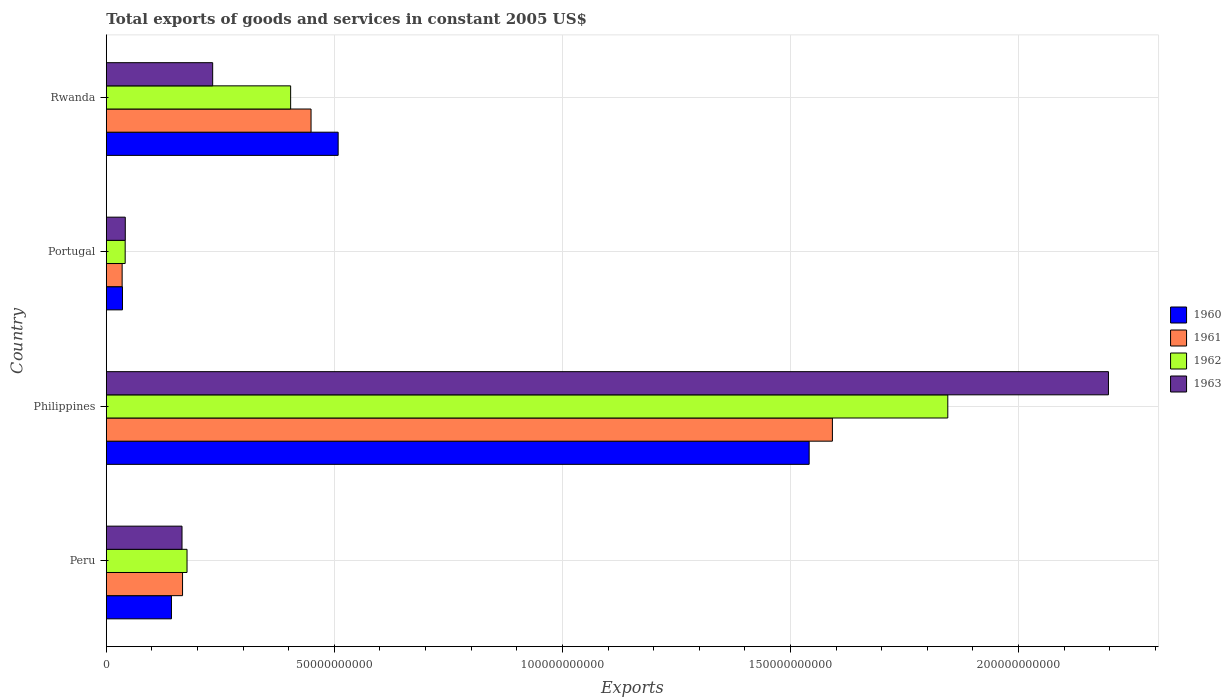How many different coloured bars are there?
Provide a short and direct response. 4. How many groups of bars are there?
Keep it short and to the point. 4. How many bars are there on the 2nd tick from the bottom?
Offer a terse response. 4. What is the label of the 4th group of bars from the top?
Give a very brief answer. Peru. What is the total exports of goods and services in 1963 in Philippines?
Ensure brevity in your answer.  2.20e+11. Across all countries, what is the maximum total exports of goods and services in 1961?
Give a very brief answer. 1.59e+11. Across all countries, what is the minimum total exports of goods and services in 1963?
Your answer should be compact. 4.16e+09. In which country was the total exports of goods and services in 1962 minimum?
Offer a very short reply. Portugal. What is the total total exports of goods and services in 1962 in the graph?
Your answer should be compact. 2.47e+11. What is the difference between the total exports of goods and services in 1960 in Philippines and that in Portugal?
Offer a terse response. 1.51e+11. What is the difference between the total exports of goods and services in 1961 in Philippines and the total exports of goods and services in 1960 in Peru?
Provide a short and direct response. 1.45e+11. What is the average total exports of goods and services in 1960 per country?
Offer a terse response. 5.57e+1. What is the difference between the total exports of goods and services in 1962 and total exports of goods and services in 1963 in Peru?
Ensure brevity in your answer.  1.10e+09. In how many countries, is the total exports of goods and services in 1962 greater than 20000000000 US$?
Offer a very short reply. 2. What is the ratio of the total exports of goods and services in 1960 in Philippines to that in Rwanda?
Offer a terse response. 3.03. Is the total exports of goods and services in 1961 in Philippines less than that in Rwanda?
Make the answer very short. No. Is the difference between the total exports of goods and services in 1962 in Peru and Portugal greater than the difference between the total exports of goods and services in 1963 in Peru and Portugal?
Your answer should be compact. Yes. What is the difference between the highest and the second highest total exports of goods and services in 1962?
Give a very brief answer. 1.44e+11. What is the difference between the highest and the lowest total exports of goods and services in 1962?
Your response must be concise. 1.80e+11. In how many countries, is the total exports of goods and services in 1961 greater than the average total exports of goods and services in 1961 taken over all countries?
Ensure brevity in your answer.  1. Is it the case that in every country, the sum of the total exports of goods and services in 1963 and total exports of goods and services in 1960 is greater than the sum of total exports of goods and services in 1961 and total exports of goods and services in 1962?
Make the answer very short. No. What does the 4th bar from the top in Portugal represents?
Provide a short and direct response. 1960. What does the 2nd bar from the bottom in Rwanda represents?
Provide a succinct answer. 1961. How many bars are there?
Offer a terse response. 16. What is the difference between two consecutive major ticks on the X-axis?
Your answer should be very brief. 5.00e+1. Are the values on the major ticks of X-axis written in scientific E-notation?
Your response must be concise. No. Where does the legend appear in the graph?
Offer a terse response. Center right. How many legend labels are there?
Your response must be concise. 4. How are the legend labels stacked?
Keep it short and to the point. Vertical. What is the title of the graph?
Provide a succinct answer. Total exports of goods and services in constant 2005 US$. What is the label or title of the X-axis?
Offer a very short reply. Exports. What is the label or title of the Y-axis?
Give a very brief answer. Country. What is the Exports in 1960 in Peru?
Your answer should be compact. 1.43e+1. What is the Exports in 1961 in Peru?
Your response must be concise. 1.67e+1. What is the Exports of 1962 in Peru?
Provide a short and direct response. 1.77e+1. What is the Exports of 1963 in Peru?
Make the answer very short. 1.66e+1. What is the Exports in 1960 in Philippines?
Ensure brevity in your answer.  1.54e+11. What is the Exports in 1961 in Philippines?
Keep it short and to the point. 1.59e+11. What is the Exports of 1962 in Philippines?
Provide a succinct answer. 1.85e+11. What is the Exports in 1963 in Philippines?
Your answer should be compact. 2.20e+11. What is the Exports of 1960 in Portugal?
Your response must be concise. 3.54e+09. What is the Exports in 1961 in Portugal?
Provide a succinct answer. 3.47e+09. What is the Exports in 1962 in Portugal?
Offer a very short reply. 4.13e+09. What is the Exports of 1963 in Portugal?
Give a very brief answer. 4.16e+09. What is the Exports of 1960 in Rwanda?
Provide a short and direct response. 5.08e+1. What is the Exports of 1961 in Rwanda?
Your answer should be very brief. 4.49e+1. What is the Exports of 1962 in Rwanda?
Ensure brevity in your answer.  4.04e+1. What is the Exports of 1963 in Rwanda?
Make the answer very short. 2.33e+1. Across all countries, what is the maximum Exports of 1960?
Your answer should be very brief. 1.54e+11. Across all countries, what is the maximum Exports in 1961?
Your response must be concise. 1.59e+11. Across all countries, what is the maximum Exports in 1962?
Offer a very short reply. 1.85e+11. Across all countries, what is the maximum Exports in 1963?
Provide a short and direct response. 2.20e+11. Across all countries, what is the minimum Exports in 1960?
Offer a terse response. 3.54e+09. Across all countries, what is the minimum Exports of 1961?
Provide a succinct answer. 3.47e+09. Across all countries, what is the minimum Exports in 1962?
Provide a succinct answer. 4.13e+09. Across all countries, what is the minimum Exports of 1963?
Your response must be concise. 4.16e+09. What is the total Exports in 1960 in the graph?
Give a very brief answer. 2.23e+11. What is the total Exports in 1961 in the graph?
Ensure brevity in your answer.  2.24e+11. What is the total Exports of 1962 in the graph?
Offer a terse response. 2.47e+11. What is the total Exports of 1963 in the graph?
Keep it short and to the point. 2.64e+11. What is the difference between the Exports of 1960 in Peru and that in Philippines?
Offer a terse response. -1.40e+11. What is the difference between the Exports of 1961 in Peru and that in Philippines?
Offer a terse response. -1.42e+11. What is the difference between the Exports of 1962 in Peru and that in Philippines?
Make the answer very short. -1.67e+11. What is the difference between the Exports of 1963 in Peru and that in Philippines?
Keep it short and to the point. -2.03e+11. What is the difference between the Exports in 1960 in Peru and that in Portugal?
Provide a short and direct response. 1.07e+1. What is the difference between the Exports of 1961 in Peru and that in Portugal?
Keep it short and to the point. 1.32e+1. What is the difference between the Exports of 1962 in Peru and that in Portugal?
Your answer should be very brief. 1.36e+1. What is the difference between the Exports in 1963 in Peru and that in Portugal?
Give a very brief answer. 1.24e+1. What is the difference between the Exports in 1960 in Peru and that in Rwanda?
Offer a very short reply. -3.66e+1. What is the difference between the Exports in 1961 in Peru and that in Rwanda?
Your response must be concise. -2.82e+1. What is the difference between the Exports of 1962 in Peru and that in Rwanda?
Ensure brevity in your answer.  -2.27e+1. What is the difference between the Exports in 1963 in Peru and that in Rwanda?
Offer a terse response. -6.72e+09. What is the difference between the Exports in 1960 in Philippines and that in Portugal?
Your response must be concise. 1.51e+11. What is the difference between the Exports of 1961 in Philippines and that in Portugal?
Your answer should be compact. 1.56e+11. What is the difference between the Exports of 1962 in Philippines and that in Portugal?
Your answer should be compact. 1.80e+11. What is the difference between the Exports in 1963 in Philippines and that in Portugal?
Make the answer very short. 2.16e+11. What is the difference between the Exports of 1960 in Philippines and that in Rwanda?
Give a very brief answer. 1.03e+11. What is the difference between the Exports of 1961 in Philippines and that in Rwanda?
Provide a succinct answer. 1.14e+11. What is the difference between the Exports in 1962 in Philippines and that in Rwanda?
Make the answer very short. 1.44e+11. What is the difference between the Exports in 1963 in Philippines and that in Rwanda?
Provide a succinct answer. 1.96e+11. What is the difference between the Exports of 1960 in Portugal and that in Rwanda?
Make the answer very short. -4.73e+1. What is the difference between the Exports in 1961 in Portugal and that in Rwanda?
Your answer should be very brief. -4.14e+1. What is the difference between the Exports in 1962 in Portugal and that in Rwanda?
Provide a short and direct response. -3.63e+1. What is the difference between the Exports in 1963 in Portugal and that in Rwanda?
Ensure brevity in your answer.  -1.92e+1. What is the difference between the Exports of 1960 in Peru and the Exports of 1961 in Philippines?
Your response must be concise. -1.45e+11. What is the difference between the Exports in 1960 in Peru and the Exports in 1962 in Philippines?
Offer a terse response. -1.70e+11. What is the difference between the Exports in 1960 in Peru and the Exports in 1963 in Philippines?
Give a very brief answer. -2.05e+11. What is the difference between the Exports in 1961 in Peru and the Exports in 1962 in Philippines?
Keep it short and to the point. -1.68e+11. What is the difference between the Exports in 1961 in Peru and the Exports in 1963 in Philippines?
Your answer should be very brief. -2.03e+11. What is the difference between the Exports in 1962 in Peru and the Exports in 1963 in Philippines?
Make the answer very short. -2.02e+11. What is the difference between the Exports in 1960 in Peru and the Exports in 1961 in Portugal?
Your answer should be very brief. 1.08e+1. What is the difference between the Exports of 1960 in Peru and the Exports of 1962 in Portugal?
Keep it short and to the point. 1.01e+1. What is the difference between the Exports in 1960 in Peru and the Exports in 1963 in Portugal?
Keep it short and to the point. 1.01e+1. What is the difference between the Exports of 1961 in Peru and the Exports of 1962 in Portugal?
Provide a short and direct response. 1.26e+1. What is the difference between the Exports of 1961 in Peru and the Exports of 1963 in Portugal?
Your response must be concise. 1.26e+1. What is the difference between the Exports of 1962 in Peru and the Exports of 1963 in Portugal?
Offer a terse response. 1.35e+1. What is the difference between the Exports of 1960 in Peru and the Exports of 1961 in Rwanda?
Give a very brief answer. -3.06e+1. What is the difference between the Exports in 1960 in Peru and the Exports in 1962 in Rwanda?
Your answer should be very brief. -2.61e+1. What is the difference between the Exports in 1960 in Peru and the Exports in 1963 in Rwanda?
Give a very brief answer. -9.04e+09. What is the difference between the Exports of 1961 in Peru and the Exports of 1962 in Rwanda?
Your response must be concise. -2.37e+1. What is the difference between the Exports of 1961 in Peru and the Exports of 1963 in Rwanda?
Your answer should be compact. -6.61e+09. What is the difference between the Exports in 1962 in Peru and the Exports in 1963 in Rwanda?
Make the answer very short. -5.62e+09. What is the difference between the Exports of 1960 in Philippines and the Exports of 1961 in Portugal?
Make the answer very short. 1.51e+11. What is the difference between the Exports in 1960 in Philippines and the Exports in 1962 in Portugal?
Your response must be concise. 1.50e+11. What is the difference between the Exports of 1960 in Philippines and the Exports of 1963 in Portugal?
Give a very brief answer. 1.50e+11. What is the difference between the Exports of 1961 in Philippines and the Exports of 1962 in Portugal?
Offer a very short reply. 1.55e+11. What is the difference between the Exports of 1961 in Philippines and the Exports of 1963 in Portugal?
Provide a succinct answer. 1.55e+11. What is the difference between the Exports of 1962 in Philippines and the Exports of 1963 in Portugal?
Your answer should be very brief. 1.80e+11. What is the difference between the Exports of 1960 in Philippines and the Exports of 1961 in Rwanda?
Provide a succinct answer. 1.09e+11. What is the difference between the Exports in 1960 in Philippines and the Exports in 1962 in Rwanda?
Your response must be concise. 1.14e+11. What is the difference between the Exports of 1960 in Philippines and the Exports of 1963 in Rwanda?
Keep it short and to the point. 1.31e+11. What is the difference between the Exports in 1961 in Philippines and the Exports in 1962 in Rwanda?
Your response must be concise. 1.19e+11. What is the difference between the Exports in 1961 in Philippines and the Exports in 1963 in Rwanda?
Make the answer very short. 1.36e+11. What is the difference between the Exports of 1962 in Philippines and the Exports of 1963 in Rwanda?
Offer a very short reply. 1.61e+11. What is the difference between the Exports of 1960 in Portugal and the Exports of 1961 in Rwanda?
Offer a very short reply. -4.13e+1. What is the difference between the Exports of 1960 in Portugal and the Exports of 1962 in Rwanda?
Keep it short and to the point. -3.69e+1. What is the difference between the Exports of 1960 in Portugal and the Exports of 1963 in Rwanda?
Give a very brief answer. -1.98e+1. What is the difference between the Exports in 1961 in Portugal and the Exports in 1962 in Rwanda?
Your answer should be compact. -3.69e+1. What is the difference between the Exports in 1961 in Portugal and the Exports in 1963 in Rwanda?
Your answer should be very brief. -1.99e+1. What is the difference between the Exports in 1962 in Portugal and the Exports in 1963 in Rwanda?
Provide a succinct answer. -1.92e+1. What is the average Exports of 1960 per country?
Give a very brief answer. 5.57e+1. What is the average Exports of 1961 per country?
Give a very brief answer. 5.61e+1. What is the average Exports in 1962 per country?
Keep it short and to the point. 6.17e+1. What is the average Exports in 1963 per country?
Ensure brevity in your answer.  6.59e+1. What is the difference between the Exports of 1960 and Exports of 1961 in Peru?
Provide a succinct answer. -2.43e+09. What is the difference between the Exports of 1960 and Exports of 1962 in Peru?
Offer a very short reply. -3.42e+09. What is the difference between the Exports in 1960 and Exports in 1963 in Peru?
Your response must be concise. -2.32e+09. What is the difference between the Exports of 1961 and Exports of 1962 in Peru?
Keep it short and to the point. -9.83e+08. What is the difference between the Exports in 1961 and Exports in 1963 in Peru?
Give a very brief answer. 1.16e+08. What is the difference between the Exports in 1962 and Exports in 1963 in Peru?
Provide a short and direct response. 1.10e+09. What is the difference between the Exports of 1960 and Exports of 1961 in Philippines?
Offer a very short reply. -5.10e+09. What is the difference between the Exports in 1960 and Exports in 1962 in Philippines?
Provide a short and direct response. -3.04e+1. What is the difference between the Exports in 1960 and Exports in 1963 in Philippines?
Your answer should be very brief. -6.56e+1. What is the difference between the Exports in 1961 and Exports in 1962 in Philippines?
Provide a short and direct response. -2.53e+1. What is the difference between the Exports in 1961 and Exports in 1963 in Philippines?
Make the answer very short. -6.05e+1. What is the difference between the Exports of 1962 and Exports of 1963 in Philippines?
Make the answer very short. -3.52e+1. What is the difference between the Exports in 1960 and Exports in 1961 in Portugal?
Give a very brief answer. 7.38e+07. What is the difference between the Exports in 1960 and Exports in 1962 in Portugal?
Make the answer very short. -5.90e+08. What is the difference between the Exports of 1960 and Exports of 1963 in Portugal?
Offer a very short reply. -6.15e+08. What is the difference between the Exports in 1961 and Exports in 1962 in Portugal?
Provide a short and direct response. -6.64e+08. What is the difference between the Exports in 1961 and Exports in 1963 in Portugal?
Make the answer very short. -6.88e+08. What is the difference between the Exports of 1962 and Exports of 1963 in Portugal?
Your answer should be compact. -2.46e+07. What is the difference between the Exports in 1960 and Exports in 1961 in Rwanda?
Offer a very short reply. 5.95e+09. What is the difference between the Exports in 1960 and Exports in 1962 in Rwanda?
Your response must be concise. 1.04e+1. What is the difference between the Exports in 1960 and Exports in 1963 in Rwanda?
Your response must be concise. 2.75e+1. What is the difference between the Exports of 1961 and Exports of 1962 in Rwanda?
Offer a terse response. 4.47e+09. What is the difference between the Exports in 1961 and Exports in 1963 in Rwanda?
Provide a short and direct response. 2.16e+1. What is the difference between the Exports in 1962 and Exports in 1963 in Rwanda?
Keep it short and to the point. 1.71e+1. What is the ratio of the Exports of 1960 in Peru to that in Philippines?
Your response must be concise. 0.09. What is the ratio of the Exports of 1961 in Peru to that in Philippines?
Provide a short and direct response. 0.1. What is the ratio of the Exports of 1962 in Peru to that in Philippines?
Your answer should be compact. 0.1. What is the ratio of the Exports in 1963 in Peru to that in Philippines?
Your response must be concise. 0.08. What is the ratio of the Exports of 1960 in Peru to that in Portugal?
Offer a very short reply. 4.03. What is the ratio of the Exports of 1961 in Peru to that in Portugal?
Give a very brief answer. 4.82. What is the ratio of the Exports in 1962 in Peru to that in Portugal?
Your response must be concise. 4.28. What is the ratio of the Exports of 1963 in Peru to that in Portugal?
Your response must be concise. 3.99. What is the ratio of the Exports of 1960 in Peru to that in Rwanda?
Provide a succinct answer. 0.28. What is the ratio of the Exports in 1961 in Peru to that in Rwanda?
Keep it short and to the point. 0.37. What is the ratio of the Exports of 1962 in Peru to that in Rwanda?
Provide a succinct answer. 0.44. What is the ratio of the Exports in 1963 in Peru to that in Rwanda?
Ensure brevity in your answer.  0.71. What is the ratio of the Exports of 1960 in Philippines to that in Portugal?
Provide a short and direct response. 43.52. What is the ratio of the Exports in 1961 in Philippines to that in Portugal?
Offer a terse response. 45.92. What is the ratio of the Exports in 1962 in Philippines to that in Portugal?
Give a very brief answer. 44.66. What is the ratio of the Exports in 1963 in Philippines to that in Portugal?
Your answer should be very brief. 52.88. What is the ratio of the Exports in 1960 in Philippines to that in Rwanda?
Your response must be concise. 3.03. What is the ratio of the Exports of 1961 in Philippines to that in Rwanda?
Keep it short and to the point. 3.55. What is the ratio of the Exports in 1962 in Philippines to that in Rwanda?
Provide a succinct answer. 4.57. What is the ratio of the Exports in 1963 in Philippines to that in Rwanda?
Your response must be concise. 9.42. What is the ratio of the Exports of 1960 in Portugal to that in Rwanda?
Your response must be concise. 0.07. What is the ratio of the Exports in 1961 in Portugal to that in Rwanda?
Provide a short and direct response. 0.08. What is the ratio of the Exports of 1962 in Portugal to that in Rwanda?
Provide a short and direct response. 0.1. What is the ratio of the Exports of 1963 in Portugal to that in Rwanda?
Give a very brief answer. 0.18. What is the difference between the highest and the second highest Exports of 1960?
Give a very brief answer. 1.03e+11. What is the difference between the highest and the second highest Exports of 1961?
Give a very brief answer. 1.14e+11. What is the difference between the highest and the second highest Exports in 1962?
Offer a terse response. 1.44e+11. What is the difference between the highest and the second highest Exports in 1963?
Your response must be concise. 1.96e+11. What is the difference between the highest and the lowest Exports of 1960?
Keep it short and to the point. 1.51e+11. What is the difference between the highest and the lowest Exports in 1961?
Provide a short and direct response. 1.56e+11. What is the difference between the highest and the lowest Exports of 1962?
Give a very brief answer. 1.80e+11. What is the difference between the highest and the lowest Exports in 1963?
Offer a terse response. 2.16e+11. 